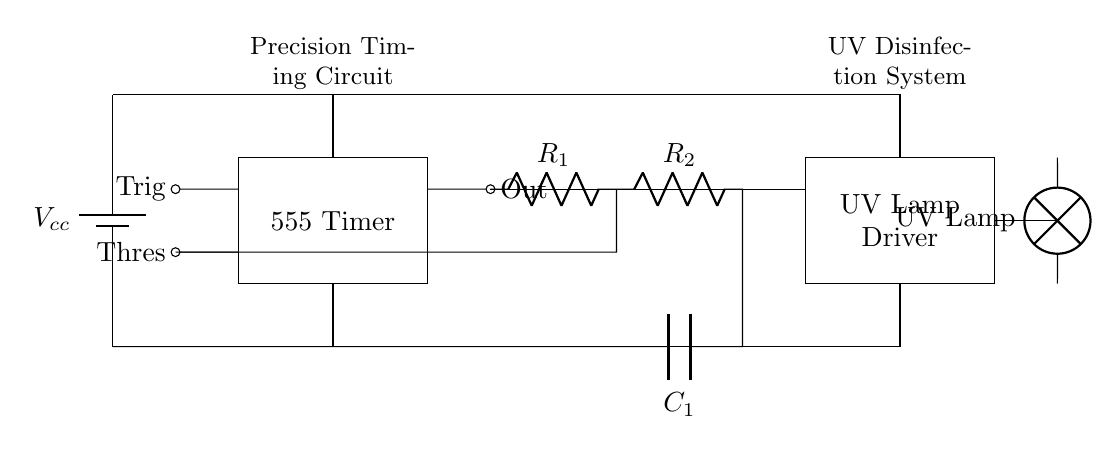What type of timer is used in this circuit? The circuit uses a 555 timer, which is indicated by the label on the diagram and commonly recognized for its timing capabilities.
Answer: 555 timer What is the purpose of the resistor labeled R1? R1 is part of the timing network for the 555 timer; it influences the charge and discharge times of the timing capacitor, thereby determining the timing interval.
Answer: Timing How many resistors are present in this circuit? There are two resistors, R1 and R2, connected in series in the timing circuit section.
Answer: Two What component drives the UV lamp in the circuit? The component labeled as the "UV Lamp Driver" controls the UV lamp, providing the necessary power to operate it.
Answer: UV Lamp Driver What is the total voltage supplied to the circuit? The voltage supplied is denoted as Vcc, and the text label indicates that it is the power supply for the entire circuit.
Answer: Vcc How does the timing capacitor affect the UV lamp operation? The timing capacitor (C1) works with the resistors R1 and R2 to set the oscillation frequency of the 555 timer, which in turn controls the on-off cycling of the UV lamp, impacting the disinfection process by regulating exposure time.
Answer: Controls on-off cycling What does the connection labeled "Out" indicate in the circuit? The "Out" connection from the 555 timer sends the output signal to the UV lamp driver, activating or deactivating the UV lamp based on the timer’s state.
Answer: Output signal 